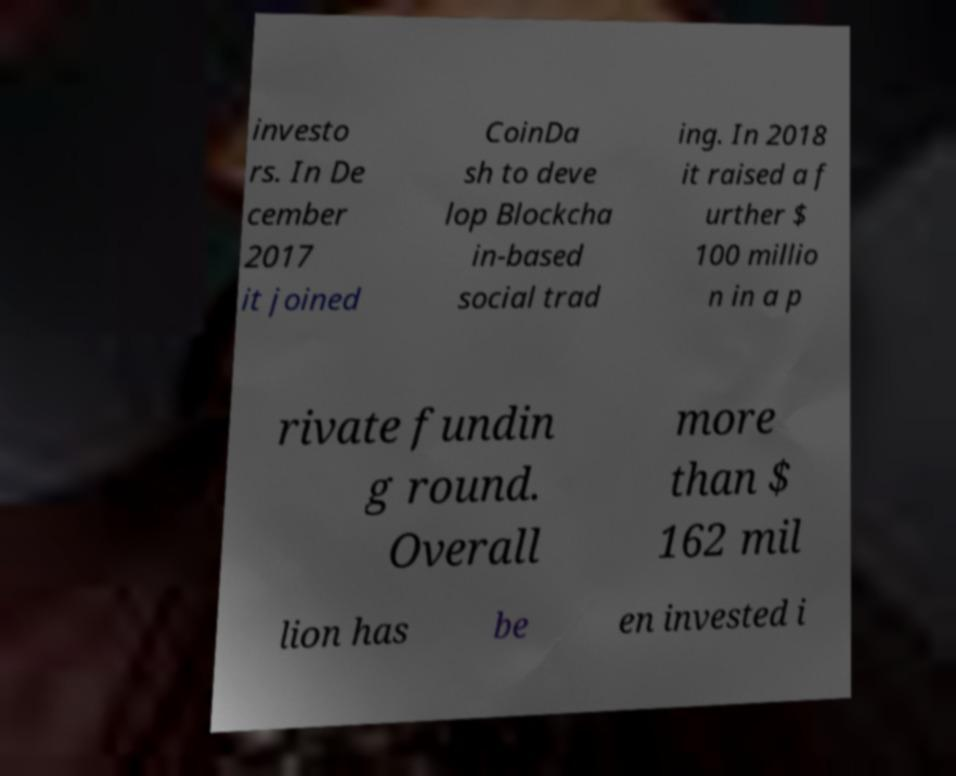Can you accurately transcribe the text from the provided image for me? investo rs. In De cember 2017 it joined CoinDa sh to deve lop Blockcha in-based social trad ing. In 2018 it raised a f urther $ 100 millio n in a p rivate fundin g round. Overall more than $ 162 mil lion has be en invested i 